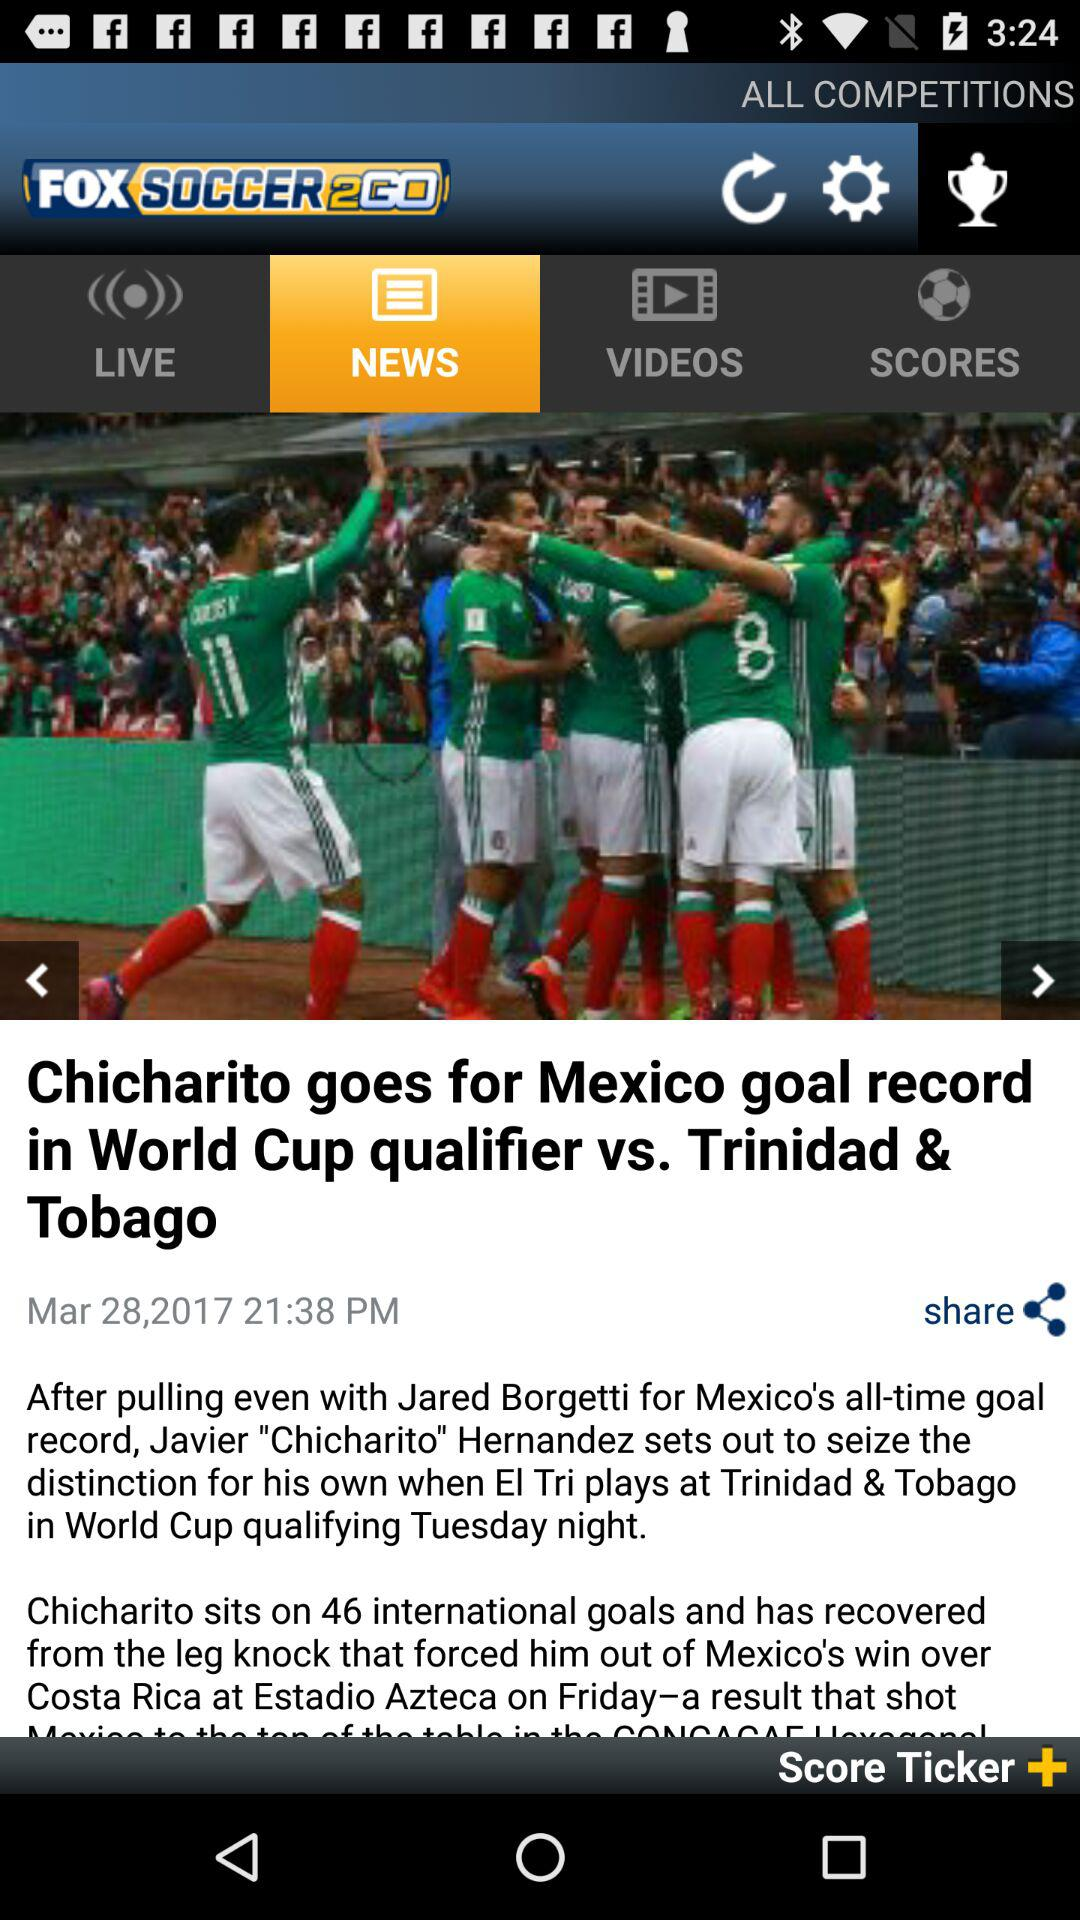Which tab is selected? The selected tab is "NEWS". 